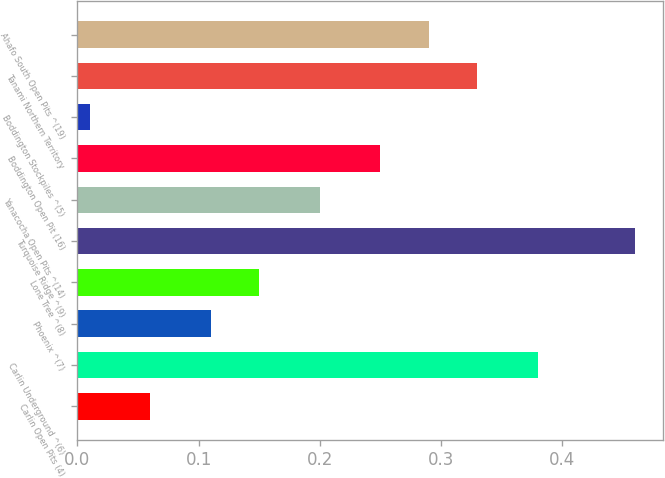Convert chart. <chart><loc_0><loc_0><loc_500><loc_500><bar_chart><fcel>Carlin Open Pits (4)<fcel>Carlin Underground ^(6)<fcel>Phoenix ^(7)<fcel>Lone Tree ^(8)<fcel>Turquoise Ridge ^(9)<fcel>Yanacocha Open Pits ^(14)<fcel>Boddington Open Pit (16)<fcel>Boddington Stockpiles ^(5)<fcel>Tanami Northern Territory<fcel>Ahafo South Open Pits ^(19)<nl><fcel>0.06<fcel>0.38<fcel>0.11<fcel>0.15<fcel>0.46<fcel>0.2<fcel>0.25<fcel>0.01<fcel>0.33<fcel>0.29<nl></chart> 